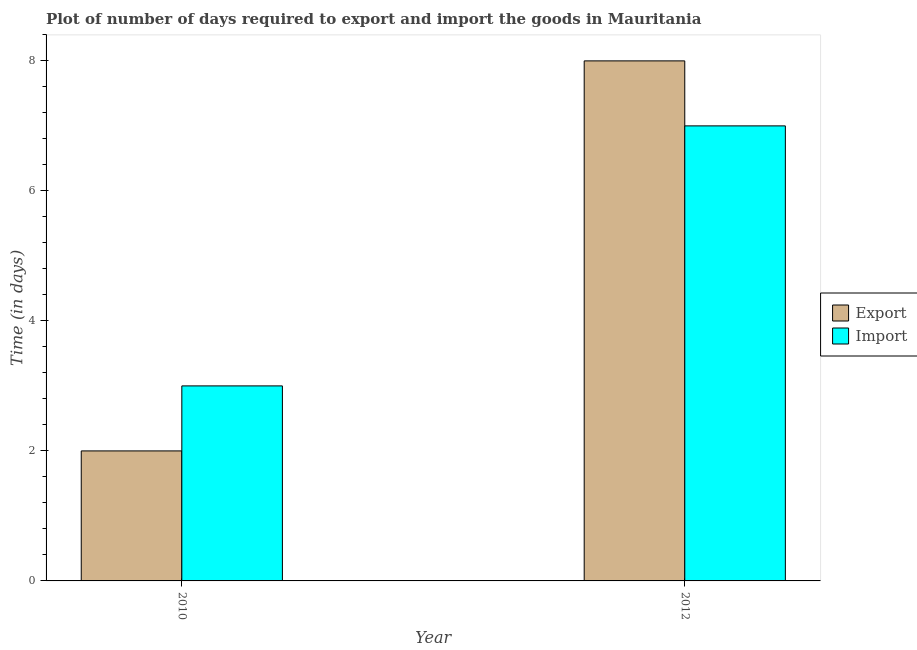How many bars are there on the 1st tick from the left?
Your answer should be very brief. 2. In how many cases, is the number of bars for a given year not equal to the number of legend labels?
Offer a very short reply. 0. What is the time required to export in 2012?
Keep it short and to the point. 8. Across all years, what is the maximum time required to import?
Give a very brief answer. 7. Across all years, what is the minimum time required to import?
Offer a very short reply. 3. In which year was the time required to export minimum?
Offer a terse response. 2010. What is the total time required to import in the graph?
Offer a terse response. 10. What is the difference between the time required to import in 2010 and that in 2012?
Give a very brief answer. -4. What is the difference between the time required to import in 2012 and the time required to export in 2010?
Make the answer very short. 4. What is the average time required to import per year?
Your answer should be very brief. 5. In the year 2012, what is the difference between the time required to import and time required to export?
Your answer should be compact. 0. In how many years, is the time required to export greater than 4.8 days?
Your answer should be very brief. 1. What is the ratio of the time required to import in 2010 to that in 2012?
Provide a short and direct response. 0.43. Is the time required to import in 2010 less than that in 2012?
Your response must be concise. Yes. In how many years, is the time required to export greater than the average time required to export taken over all years?
Offer a terse response. 1. What does the 2nd bar from the left in 2010 represents?
Your answer should be very brief. Import. What does the 1st bar from the right in 2010 represents?
Give a very brief answer. Import. How many bars are there?
Your answer should be very brief. 4. How many years are there in the graph?
Your answer should be very brief. 2. What is the difference between two consecutive major ticks on the Y-axis?
Offer a very short reply. 2. Are the values on the major ticks of Y-axis written in scientific E-notation?
Give a very brief answer. No. Does the graph contain any zero values?
Your answer should be compact. No. Where does the legend appear in the graph?
Your response must be concise. Center right. What is the title of the graph?
Offer a terse response. Plot of number of days required to export and import the goods in Mauritania. Does "Fixed telephone" appear as one of the legend labels in the graph?
Give a very brief answer. No. What is the label or title of the Y-axis?
Provide a short and direct response. Time (in days). What is the Time (in days) of Import in 2010?
Provide a succinct answer. 3. What is the Time (in days) of Export in 2012?
Your response must be concise. 8. Across all years, what is the maximum Time (in days) in Export?
Ensure brevity in your answer.  8. Across all years, what is the minimum Time (in days) in Export?
Your answer should be very brief. 2. What is the total Time (in days) of Export in the graph?
Your answer should be very brief. 10. In the year 2012, what is the difference between the Time (in days) of Export and Time (in days) of Import?
Your answer should be compact. 1. What is the ratio of the Time (in days) of Import in 2010 to that in 2012?
Offer a terse response. 0.43. What is the difference between the highest and the lowest Time (in days) of Export?
Your response must be concise. 6. What is the difference between the highest and the lowest Time (in days) of Import?
Your response must be concise. 4. 